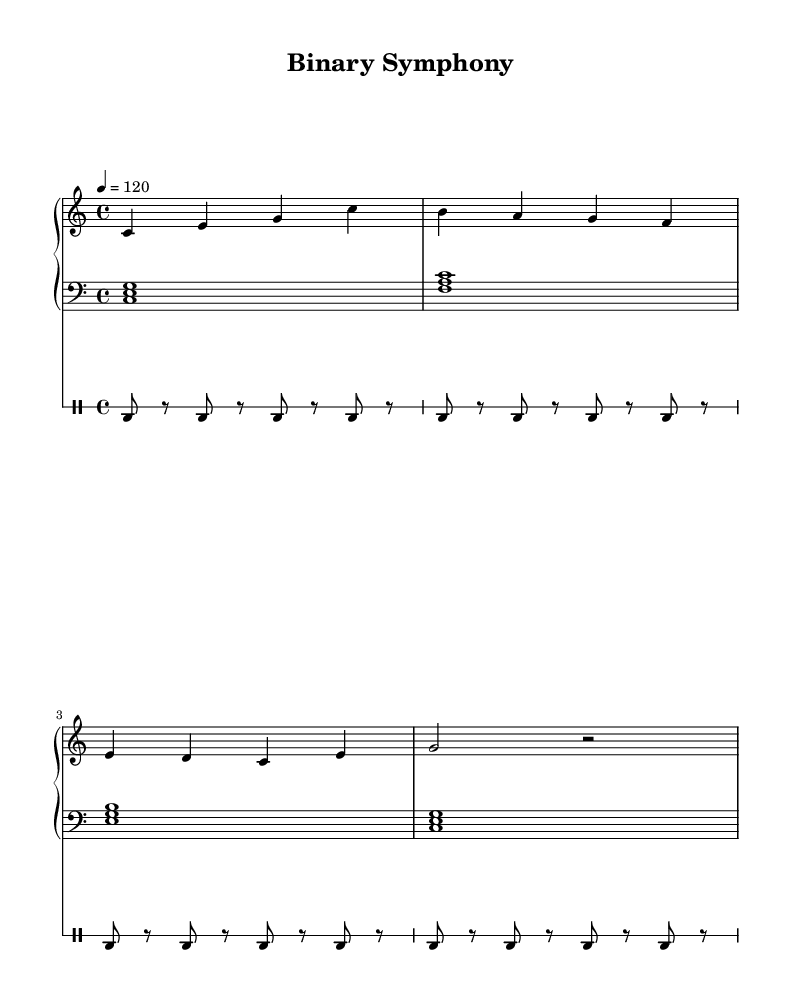What is the key signature of this music? The key signature is indicated at the beginning of the sheet music and shows no sharps or flats, confirming it is in C major.
Answer: C major What is the time signature of the piece? The time signature is found at the start of the sheet music, showing that there are four beats in a measure, confirming a 4/4 time signature.
Answer: 4/4 What is the tempo marking for this music? The tempo marking is shown at the beginning and indicates a speed of 120 beats per minute, which is a moderate tempo for the piece.
Answer: 120 How many measures are in the right-hand piano part? By counting the vertical lines (bar lines) in the right-hand piano part, it is observed that there are four measures in total.
Answer: 4 What is the primary instrumentation of this piece? The piece consists of two main elements: a Piano Staff for the piano and a Drum Staff for the electronic beats. This combination defines it as a fusion of piano and electronic music.
Answer: Piano and drums What type of drum is primarily used in the electronic part? By analyzing the drum notation, it is indicated that the bass drum (bd) is consistently played throughout the piece, establishing it as the central drum used.
Answer: Bass drum What is the rhythmic pattern of the left-hand piano part? The left-hand piano part consists of whole-note chords played steadily without any additional rhythmic variation, providing a foundational harmonic support to the piece.
Answer: Whole notes 